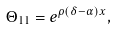Convert formula to latex. <formula><loc_0><loc_0><loc_500><loc_500>\Theta _ { 1 1 } = e ^ { \rho \left ( \delta - \alpha \right ) x } ,</formula> 